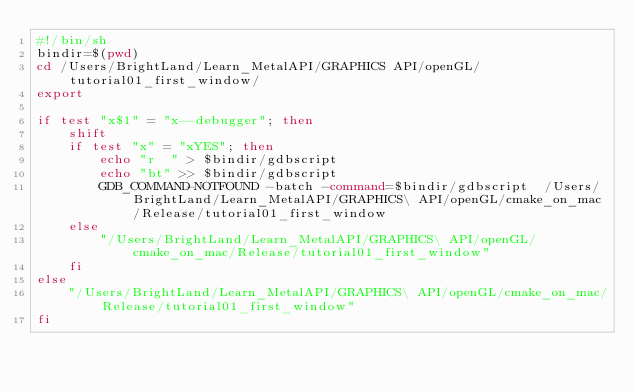<code> <loc_0><loc_0><loc_500><loc_500><_Bash_>#!/bin/sh
bindir=$(pwd)
cd /Users/BrightLand/Learn_MetalAPI/GRAPHICS API/openGL/tutorial01_first_window/
export 

if test "x$1" = "x--debugger"; then
	shift
	if test "x" = "xYES"; then
		echo "r  " > $bindir/gdbscript
		echo "bt" >> $bindir/gdbscript
		GDB_COMMAND-NOTFOUND -batch -command=$bindir/gdbscript  /Users/BrightLand/Learn_MetalAPI/GRAPHICS\ API/openGL/cmake_on_mac/Release/tutorial01_first_window 
	else
		"/Users/BrightLand/Learn_MetalAPI/GRAPHICS\ API/openGL/cmake_on_mac/Release/tutorial01_first_window"  
	fi
else
	"/Users/BrightLand/Learn_MetalAPI/GRAPHICS\ API/openGL/cmake_on_mac/Release/tutorial01_first_window"  
fi
</code> 